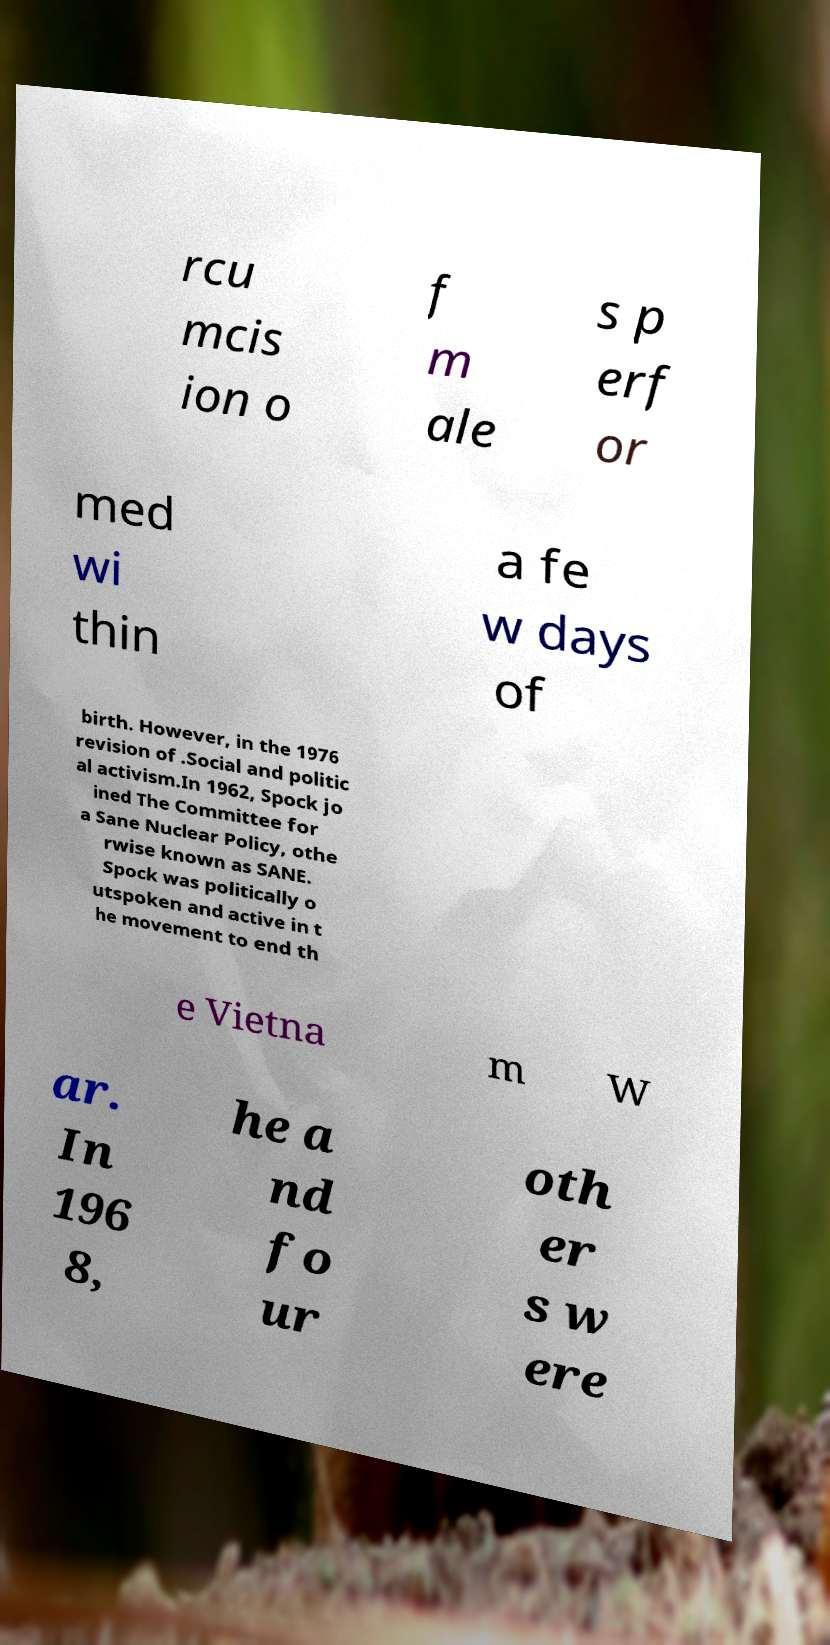There's text embedded in this image that I need extracted. Can you transcribe it verbatim? rcu mcis ion o f m ale s p erf or med wi thin a fe w days of birth. However, in the 1976 revision of .Social and politic al activism.In 1962, Spock jo ined The Committee for a Sane Nuclear Policy, othe rwise known as SANE. Spock was politically o utspoken and active in t he movement to end th e Vietna m W ar. In 196 8, he a nd fo ur oth er s w ere 